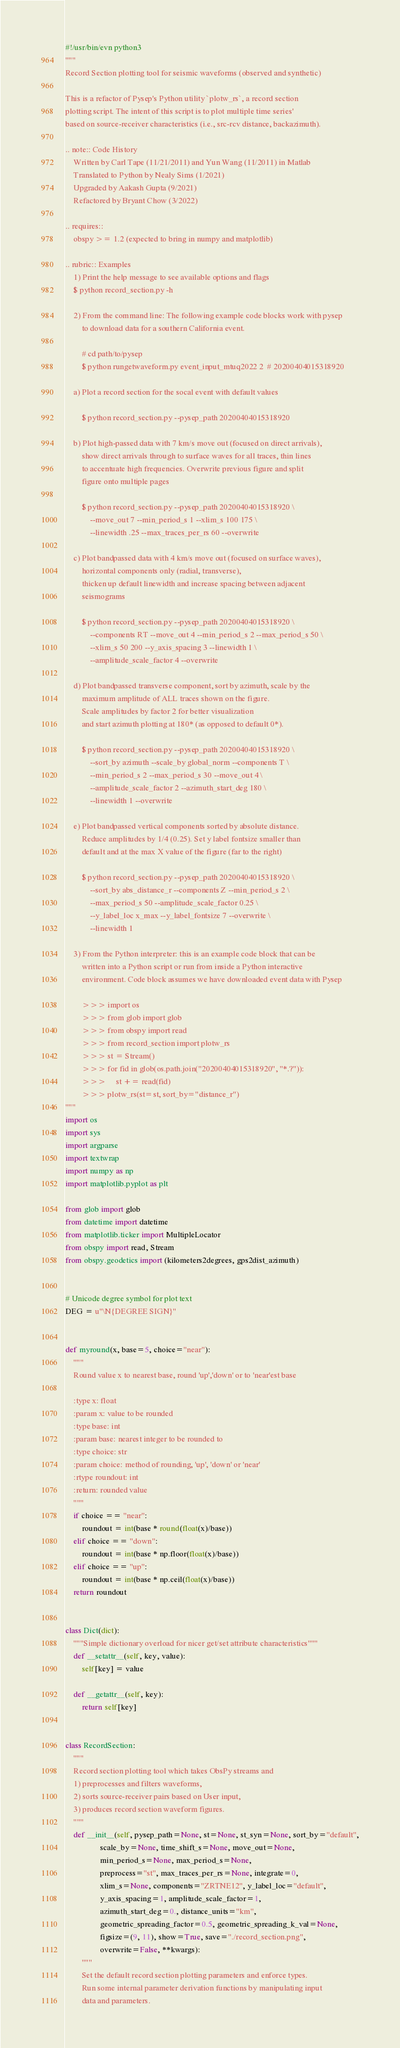Convert code to text. <code><loc_0><loc_0><loc_500><loc_500><_Python_>#!/usr/bin/evn python3
"""
Record Section plotting tool for seismic waveforms (observed and synthetic)

This is a refactor of Pysep's Python utility `plotw_rs`, a record section
plotting script. The intent of this script is to plot multiple time series'
based on source-receiver characteristics (i.e., src-rcv distance, backazimuth).

.. note:: Code History
    Written by Carl Tape (11/21/2011) and Yun Wang (11/2011) in Matlab
    Translated to Python by Nealy Sims (1/2021)
    Upgraded by Aakash Gupta (9/2021)
    Refactored by Bryant Chow (3/2022)

.. requires::
    obspy >= 1.2 (expected to bring in numpy and matplotlib)

.. rubric:: Examples
    1) Print the help message to see available options and flags
    $ python record_section.py -h

    2) From the command line: The following example code blocks work with pysep 
        to download data for a southern California event.

        # cd path/to/pysep
        $ python rungetwaveform.py event_input_mtuq2022 2  # 20200404015318920

    a) Plot a record section for the socal event with default values

        $ python record_section.py --pysep_path 20200404015318920 

    b) Plot high-passed data with 7 km/s move out (focused on direct arrivals),
        show direct arrivals through to surface waves for all traces, thin lines
        to accentuate high frequencies. Overwrite previous figure and split
        figure onto multiple pages

        $ python record_section.py --pysep_path 20200404015318920 \
            --move_out 7 --min_period_s 1 --xlim_s 100 175 \
            --linewidth .25 --max_traces_per_rs 60 --overwrite

    c) Plot bandpassed data with 4 km/s move out (focused on surface waves),
        horizontal components only (radial, transverse),
        thicken up default linewidth and increase spacing between adjacent 
        seismograms 

        $ python record_section.py --pysep_path 20200404015318920 \
            --components RT --move_out 4 --min_period_s 2 --max_period_s 50 \
            --xlim_s 50 200 --y_axis_spacing 3 --linewidth 1 \
            --amplitude_scale_factor 4 --overwrite 

    d) Plot bandpassed transverse component, sort by azimuth, scale by the 
        maximum amplitude of ALL traces shown on the figure. 
        Scale amplitudes by factor 2 for better visualization
        and start azimuth plotting at 180* (as opposed to default 0*).

        $ python record_section.py --pysep_path 20200404015318920 \
            --sort_by azimuth --scale_by global_norm --components T \
            --min_period_s 2 --max_period_s 30 --move_out 4 \
            --amplitude_scale_factor 2 --azimuth_start_deg 180 \
            --linewidth 1 --overwrite

    e) Plot bandpassed vertical components sorted by absolute distance.
        Reduce amplitudes by 1/4 (0.25). Set y label fontsize smaller than 
        default and at the max X value of the figure (far to the right)

        $ python record_section.py --pysep_path 20200404015318920 \
            --sort_by abs_distance_r --components Z --min_period_s 2 \
            --max_period_s 50 --amplitude_scale_factor 0.25 \
            --y_label_loc x_max --y_label_fontsize 7 --overwrite \
            --linewidth 1

    3) From the Python interpreter: this is an example code block that can be
        written into a Python script or run from inside a Python interactive 
        environment. Code block assumes we have downloaded event data with Pysep

        >>> import os
        >>> from glob import glob
        >>> from obspy import read
        >>> from record_section import plotw_rs
        >>> st = Stream()
        >>> for fid in glob(os.path.join("20200404015318920", "*.?")):
        >>>     st += read(fid)
        >>> plotw_rs(st=st, sort_by="distance_r")
"""
import os
import sys
import argparse
import textwrap
import numpy as np
import matplotlib.pyplot as plt

from glob import glob
from datetime import datetime
from matplotlib.ticker import MultipleLocator
from obspy import read, Stream
from obspy.geodetics import (kilometers2degrees, gps2dist_azimuth)


# Unicode degree symbol for plot text
DEG = u"\N{DEGREE SIGN}"


def myround(x, base=5, choice="near"):
    """
    Round value x to nearest base, round 'up','down' or to 'near'est base

    :type x: float
    :param x: value to be rounded
    :type base: int
    :param base: nearest integer to be rounded to
    :type choice: str
    :param choice: method of rounding, 'up', 'down' or 'near'
    :rtype roundout: int
    :return: rounded value
    """
    if choice == "near":
        roundout = int(base * round(float(x)/base))
    elif choice == "down":
        roundout = int(base * np.floor(float(x)/base))
    elif choice == "up":
        roundout = int(base * np.ceil(float(x)/base))
    return roundout


class Dict(dict):
    """Simple dictionary overload for nicer get/set attribute characteristics"""
    def __setattr__(self, key, value):
        self[key] = value

    def __getattr__(self, key):
        return self[key]


class RecordSection:
    """
    Record section plotting tool which takes ObsPy streams and 
    1) preprocesses and filters waveforms,
    2) sorts source-receiver pairs based on User input, 
    3) produces record section waveform figures.
    """
    def __init__(self, pysep_path=None, st=None, st_syn=None, sort_by="default",
                 scale_by=None, time_shift_s=None, move_out=None,
                 min_period_s=None, max_period_s=None,
                 preprocess="st", max_traces_per_rs=None, integrate=0,
                 xlim_s=None, components="ZRTNE12", y_label_loc="default",
                 y_axis_spacing=1, amplitude_scale_factor=1, 
                 azimuth_start_deg=0., distance_units="km", 
                 geometric_spreading_factor=0.5, geometric_spreading_k_val=None, 
                 figsize=(9, 11), show=True, save="./record_section.png", 
                 overwrite=False, **kwargs):
        """
        Set the default record section plotting parameters and enforce types.
        Run some internal parameter derivation functions by manipulating input
        data and parameters.
</code> 